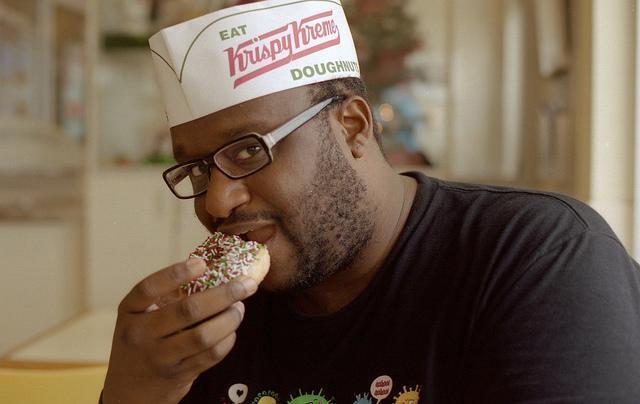How many lights on the bus are on?
Give a very brief answer. 0. 